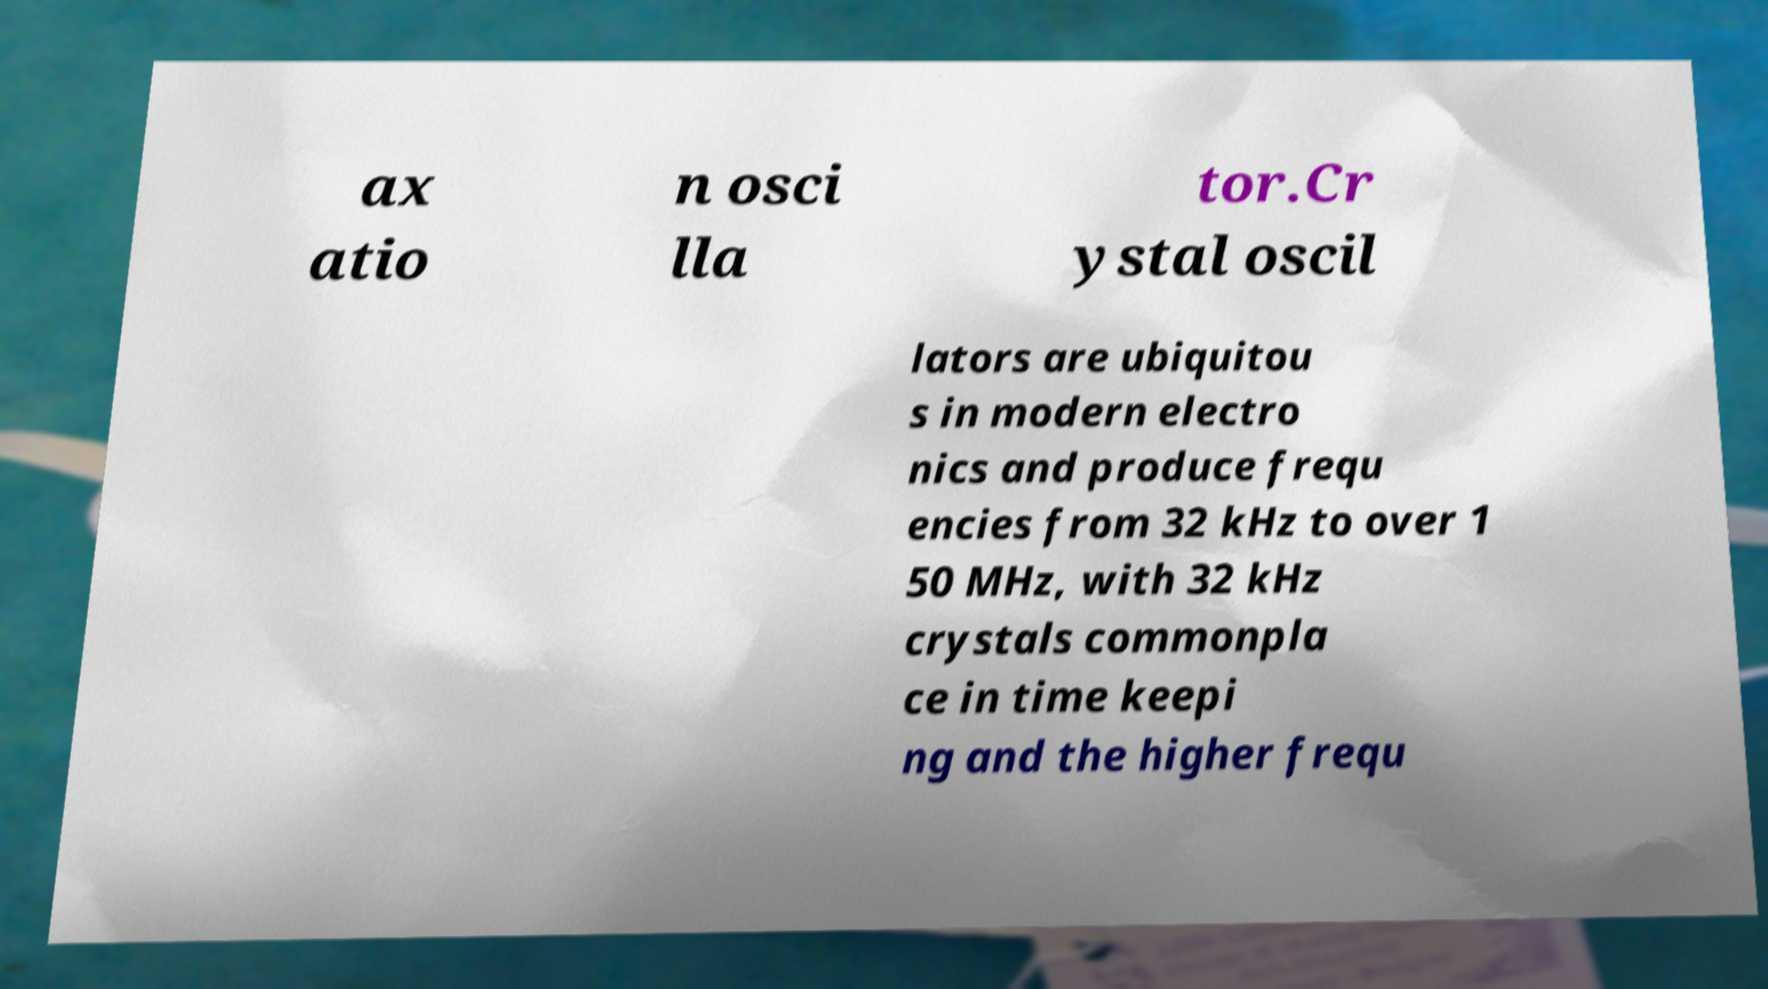I need the written content from this picture converted into text. Can you do that? ax atio n osci lla tor.Cr ystal oscil lators are ubiquitou s in modern electro nics and produce frequ encies from 32 kHz to over 1 50 MHz, with 32 kHz crystals commonpla ce in time keepi ng and the higher frequ 